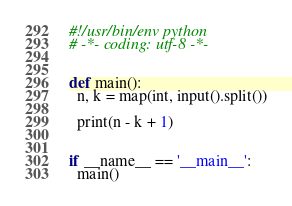<code> <loc_0><loc_0><loc_500><loc_500><_Python_>#!/usr/bin/env python
# -*- coding: utf-8 -*-


def main():
  n, k = map(int, input().split())

  print(n - k + 1)


if __name__ == '__main__':
  main()

</code> 